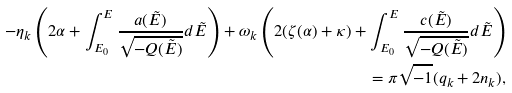<formula> <loc_0><loc_0><loc_500><loc_500>- \eta _ { k } \left ( 2 \alpha + \int _ { E _ { 0 } } ^ { E } \frac { a ( \tilde { E } ) } { \sqrt { - Q ( \tilde { E } ) } } d \tilde { E } \right ) + \omega _ { k } \left ( 2 ( \zeta ( \alpha ) + \kappa ) + \int _ { E _ { 0 } } ^ { E } \frac { c ( \tilde { E } ) } { \sqrt { - Q ( \tilde { E } ) } } d \tilde { E } \right ) & \\ = \pi \sqrt { - 1 } ( q _ { k } + 2 n _ { k } ) , &</formula> 